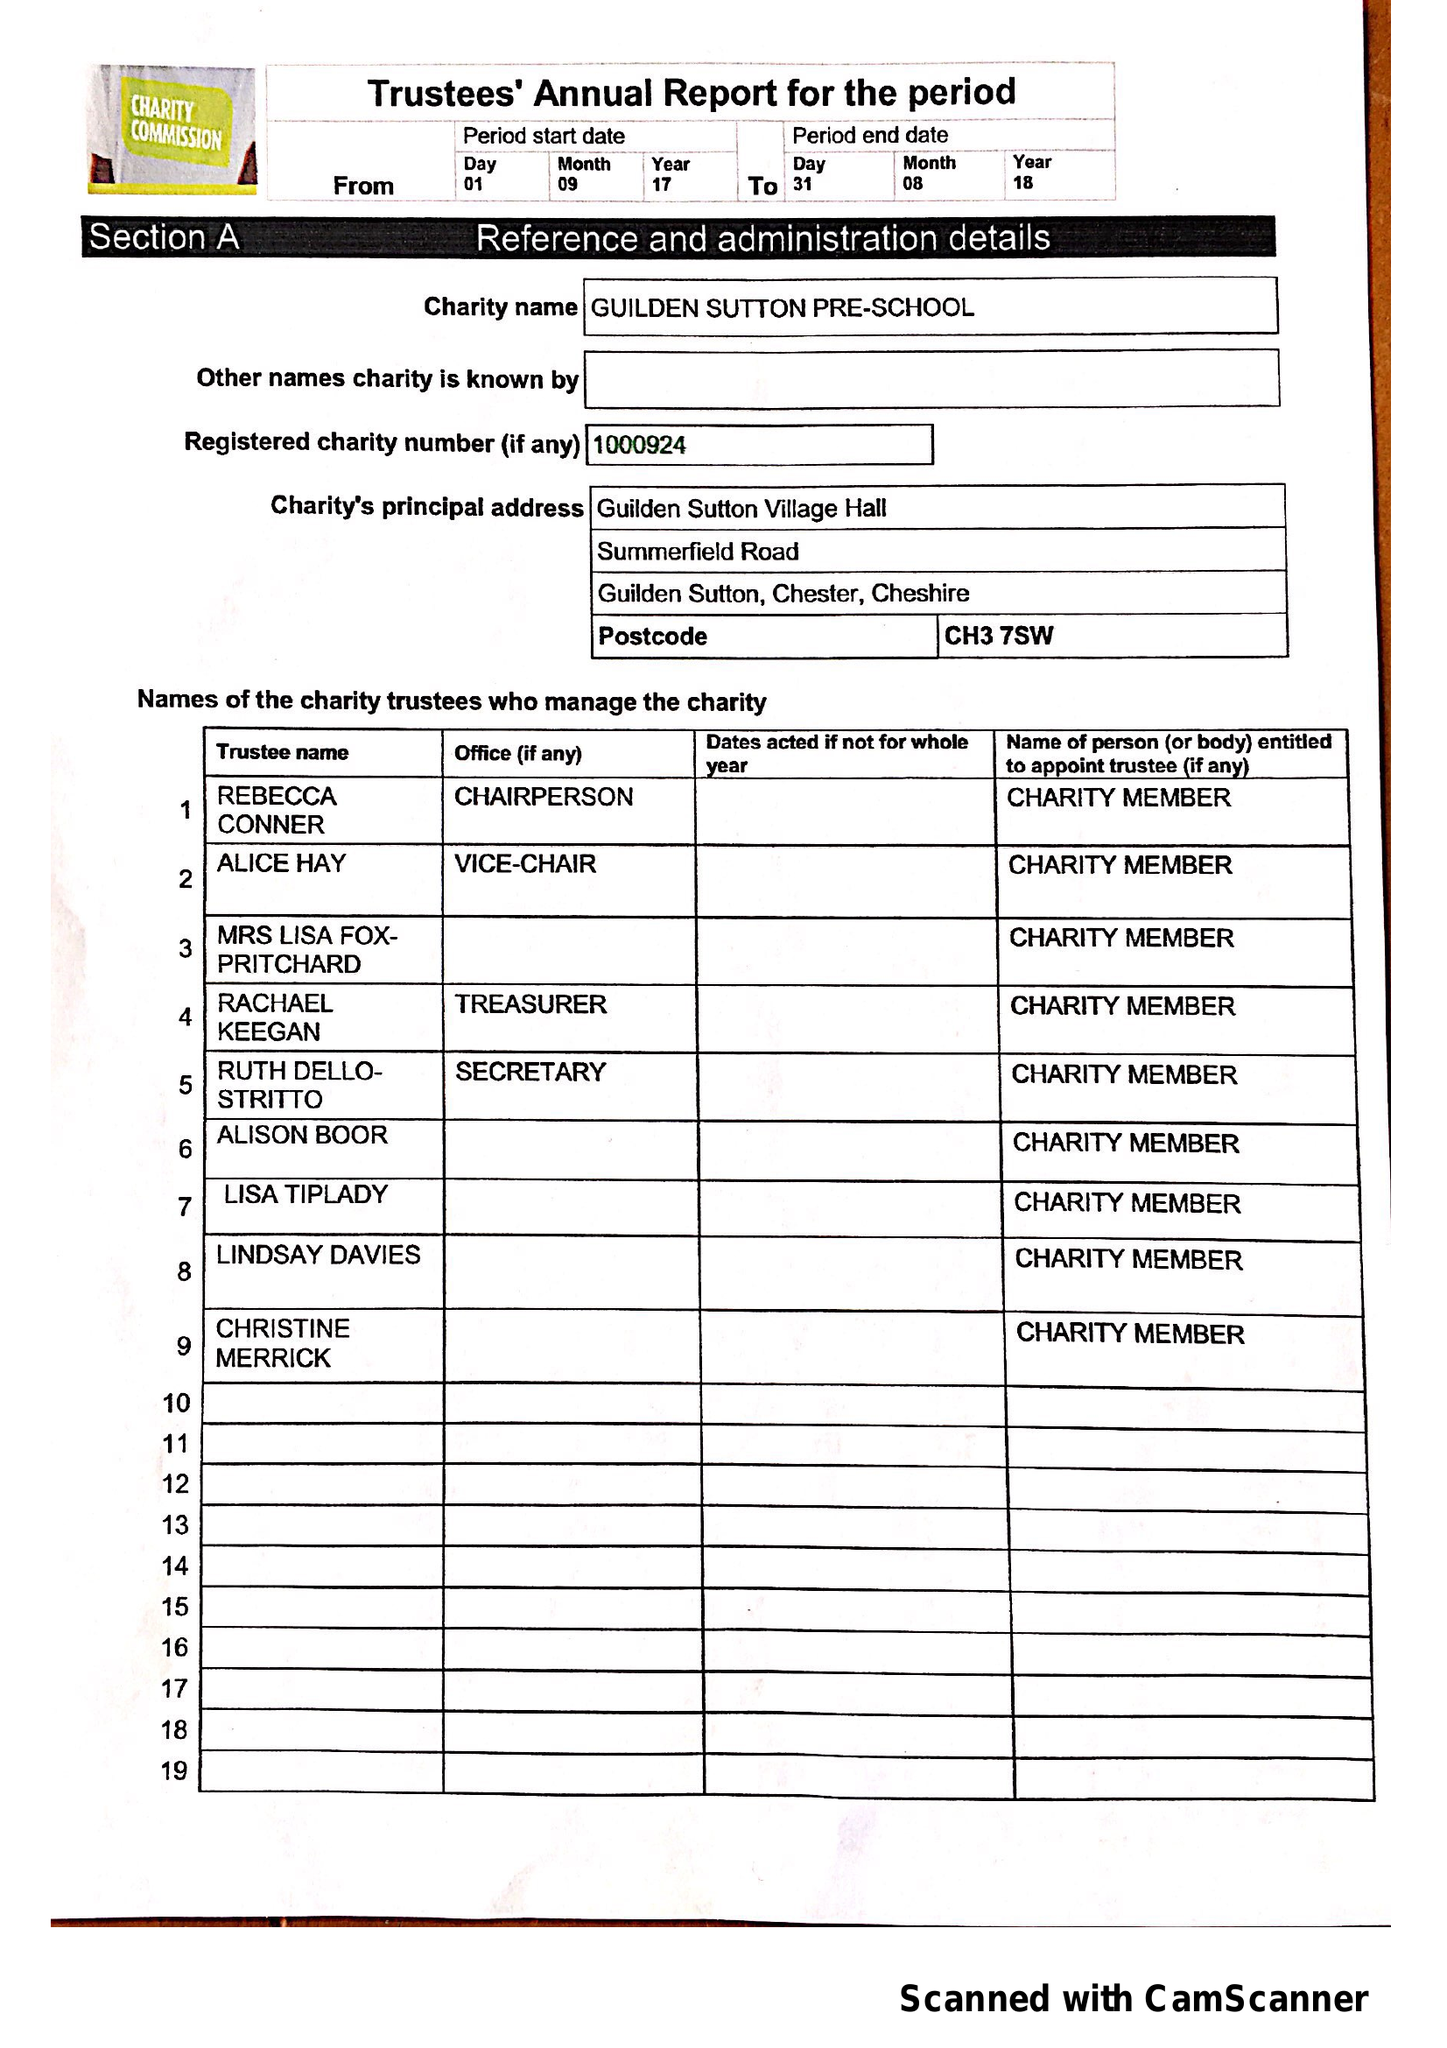What is the value for the income_annually_in_british_pounds?
Answer the question using a single word or phrase. 31472.47 